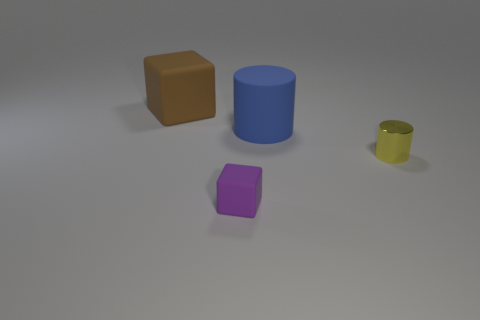Add 4 tiny purple rubber objects. How many objects exist? 8 Add 2 tiny cyan rubber cubes. How many tiny cyan rubber cubes exist? 2 Subtract 0 green spheres. How many objects are left? 4 Subtract all yellow things. Subtract all cyan rubber blocks. How many objects are left? 3 Add 4 metallic objects. How many metallic objects are left? 5 